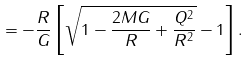<formula> <loc_0><loc_0><loc_500><loc_500>= - \frac { R } { G } \left [ \sqrt { 1 - \frac { 2 M G } { R } + \frac { Q ^ { 2 } } { R ^ { 2 } } } - 1 \right ] .</formula> 